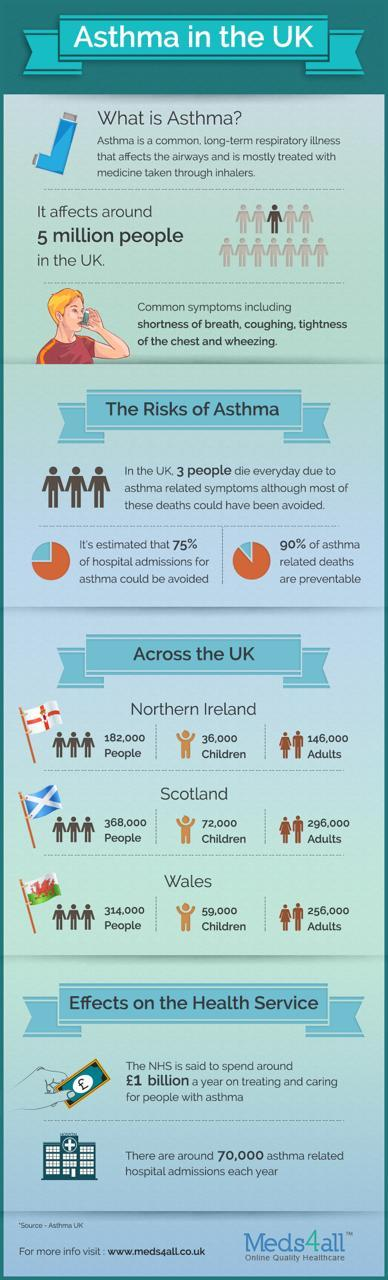How many Adults are suffering from Asthma in Northern Island ?
Answer the question with a short phrase. 146,000 How many children in Wales are suffering from Asthma? 59,000 How many risks of Asthma is listed in the infographic? 3 How many children in Northern Island are suffering from Asthma? 36,000 How many Adults are suffering from Asthma in Wales ? 256,000 How many symptoms of Asthma is listed in the infographic? 3 How many Adults are suffering from Asthma in Scotland ? 296,000 What percentage of Asthma related hospital issues can be avoided if properly treated? 75% How many children in Scotland are suffering from Asthma? 72,000 What percentage of deaths due to Asthma cannot be prevented? 10 